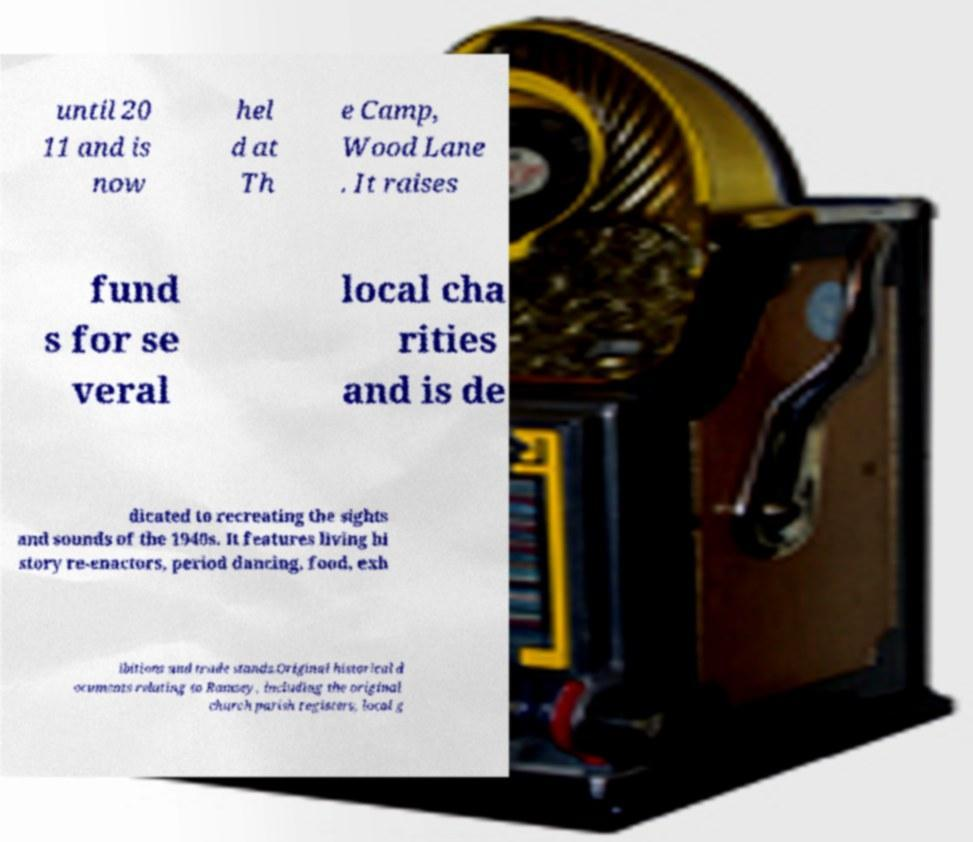What messages or text are displayed in this image? I need them in a readable, typed format. until 20 11 and is now hel d at Th e Camp, Wood Lane . It raises fund s for se veral local cha rities and is de dicated to recreating the sights and sounds of the 1940s. It features living hi story re-enactors, period dancing, food, exh ibitions and trade stands.Original historical d ocuments relating to Ramsey, including the original church parish registers, local g 